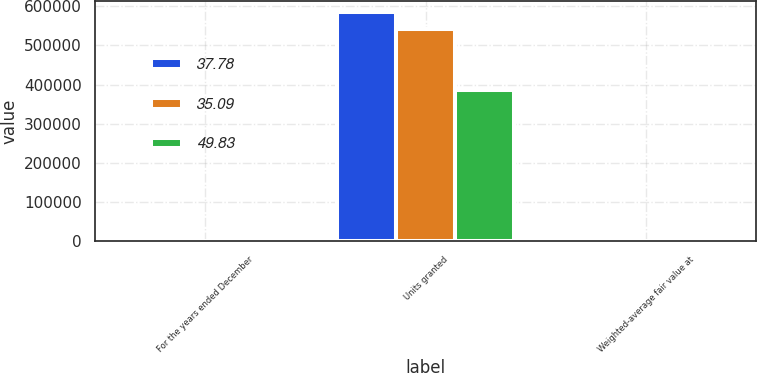Convert chart. <chart><loc_0><loc_0><loc_500><loc_500><stacked_bar_chart><ecel><fcel>For the years ended December<fcel>Units granted<fcel>Weighted-average fair value at<nl><fcel>37.78<fcel>2009<fcel>583864<fcel>35.09<nl><fcel>35.09<fcel>2008<fcel>541623<fcel>37.78<nl><fcel>49.83<fcel>2007<fcel>387143<fcel>49.83<nl></chart> 